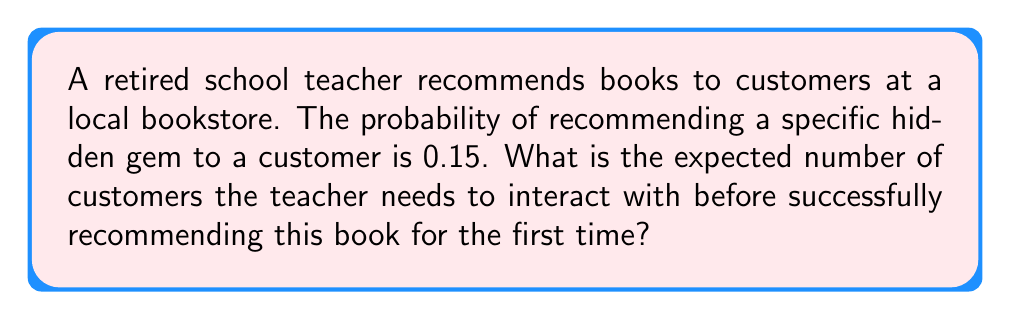Provide a solution to this math problem. To solve this problem, we need to recognize that this scenario follows a geometric distribution. The geometric distribution models the number of trials needed to achieve the first success in a series of independent Bernoulli trials.

Let's approach this step-by-step:

1) Let $X$ be the random variable representing the number of customers needed before the first successful recommendation.

2) The probability of success (recommending the book) for each customer is $p = 0.15$.

3) For a geometric distribution, the expected value (mean) is given by the formula:

   $$E[X] = \frac{1}{p}$$

4) Substituting our value of $p$:

   $$E[X] = \frac{1}{0.15}$$

5) Calculating this:

   $$E[X] = 6.67$$

Therefore, the expected number of customers the teacher needs to interact with before successfully recommending this book for the first time is approximately 6.67 customers.
Answer: $\frac{1}{0.15} \approx 6.67$ customers 